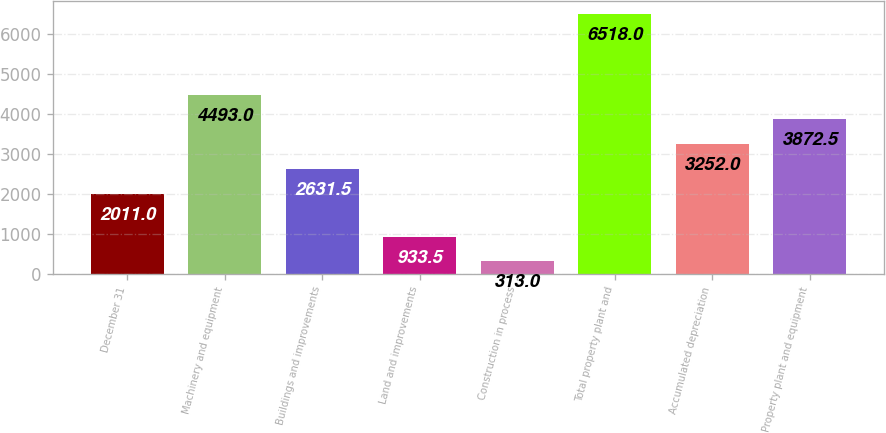Convert chart. <chart><loc_0><loc_0><loc_500><loc_500><bar_chart><fcel>December 31<fcel>Machinery and equipment<fcel>Buildings and improvements<fcel>Land and improvements<fcel>Construction in process<fcel>Total property plant and<fcel>Accumulated depreciation<fcel>Property plant and equipment<nl><fcel>2011<fcel>4493<fcel>2631.5<fcel>933.5<fcel>313<fcel>6518<fcel>3252<fcel>3872.5<nl></chart> 